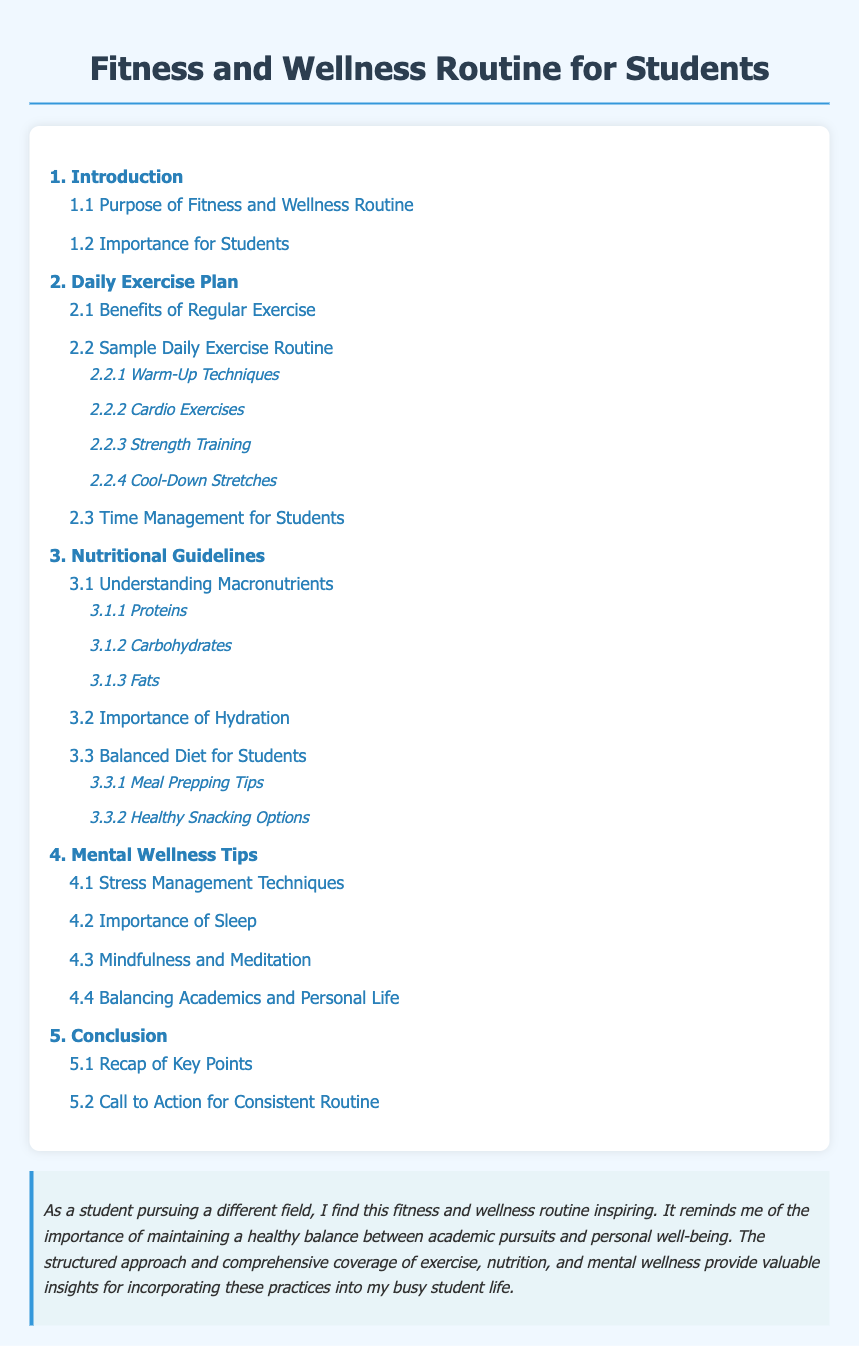What is the purpose of the fitness and wellness routine? The purpose is outlined in the document section titled "1.1 Purpose of Fitness and Wellness Routine."
Answer: Purpose of Fitness and Wellness Routine What are the benefits of regular exercise? The benefits are discussed in section "2.1 Benefits of Regular Exercise."
Answer: Benefits of Regular Exercise How many main sections are in the document? The main sections are numbered in the Table of Contents, totaling to five.
Answer: Five What section discusses stress management techniques? This topic can be found in "4.1 Stress Management Techniques."
Answer: 4.1 Stress Management Techniques What are the three types of macronutrients mentioned? The document includes specific sections for proteins, carbohydrates, and fats.
Answer: Proteins, Carbohydrates, Fats Which subsection covers meal prepping tips? Meal prepping tips are covered in "3.3.1 Meal Prepping Tips."
Answer: 3.3.1 Meal Prepping Tips What is the last section of the document? The final section is titled "5. Conclusion."
Answer: 5. Conclusion What main topic is covered in section 4? The fourth section focuses on mental wellness tips.
Answer: Mental Wellness Tips What is emphasized in the student note at the end? The note emphasizes the importance of maintaining a healthy balance between academic pursuits and personal well-being.
Answer: Maintaining a healthy balance 